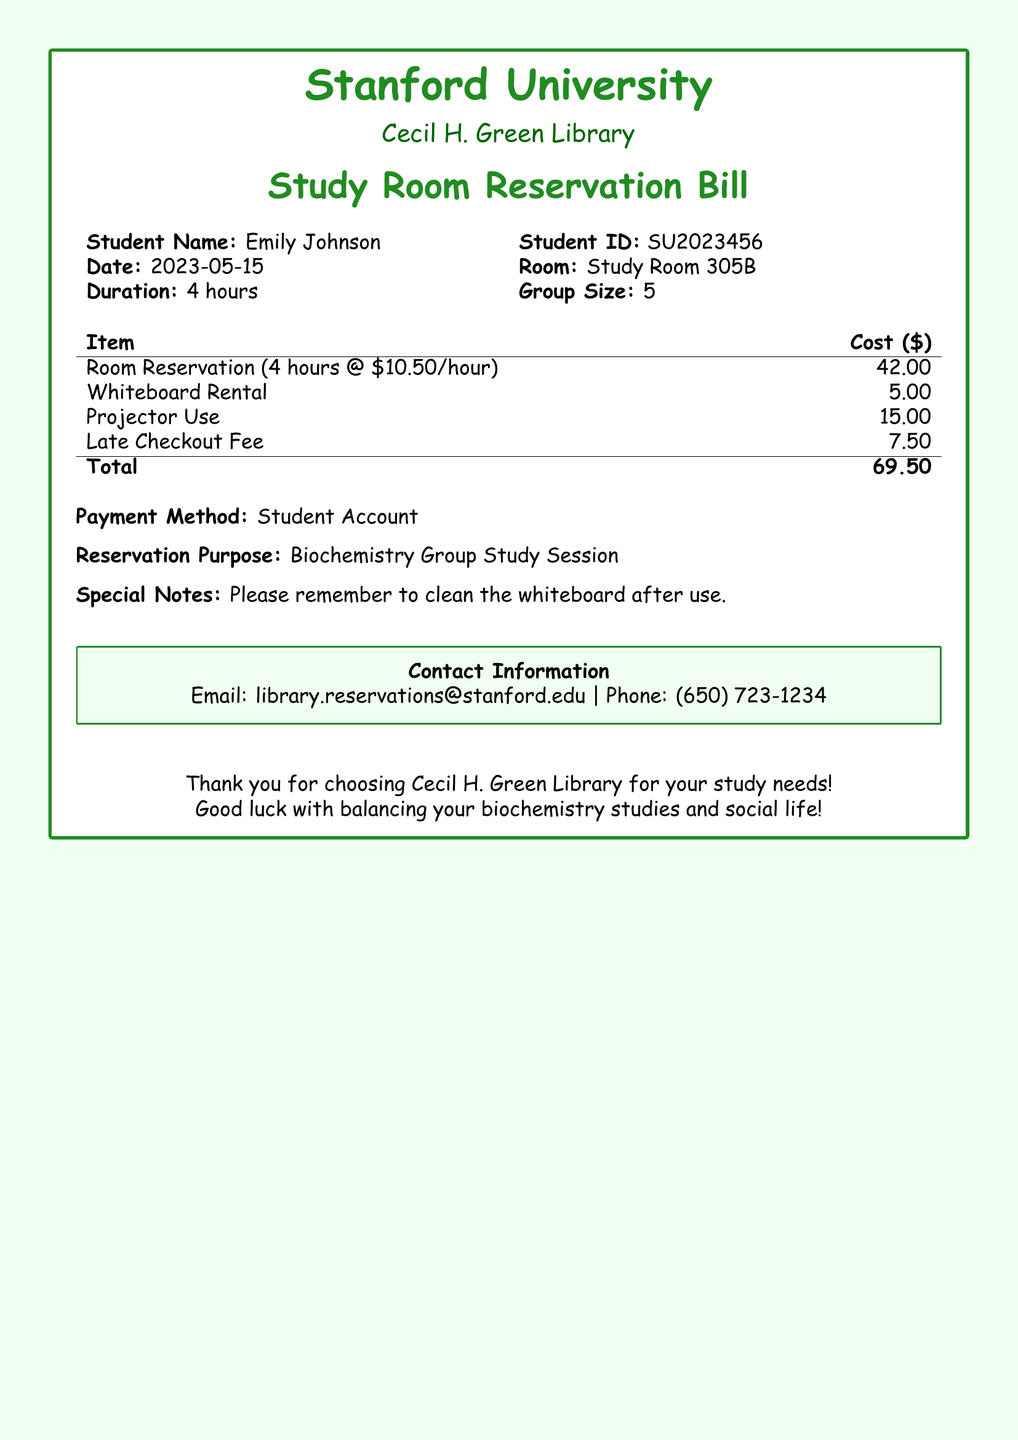What is the student's name? The student's name is mentioned directly in the bill as "Emily Johnson."
Answer: Emily Johnson What is the student ID? The student ID is provided in the document, listed as "SU2023456."
Answer: SU2023456 What is the total cost of the reservation? The total cost is clearly stated at the bottom of the bill as "69.50."
Answer: 69.50 How long was the room reserved? The duration of the reservation is specified as "4 hours."
Answer: 4 hours What additional service had a cost of $15.00? The additional service for projector use is listed with a cost of "15.00."
Answer: Projector Use What was the purpose of the reservation? The purpose of the reservation is stated as "Biochemistry Group Study Session."
Answer: Biochemistry Group Study Session If the room is reserved for 4 hours, what is the hourly rate? The bill shows that the hourly rate for the room reservation is "10.50."
Answer: 10.50 Was there a late checkout fee? A late checkout fee is included in the itemized list for "7.50."
Answer: Yes What was the rented item that cost $5.00? The rented item is explicitly listed as "Whiteboard Rental."
Answer: Whiteboard Rental What is the email contact for reservations? The email for reservations is provided as part of the contact information in the document.
Answer: library.reservations@stanford.edu 